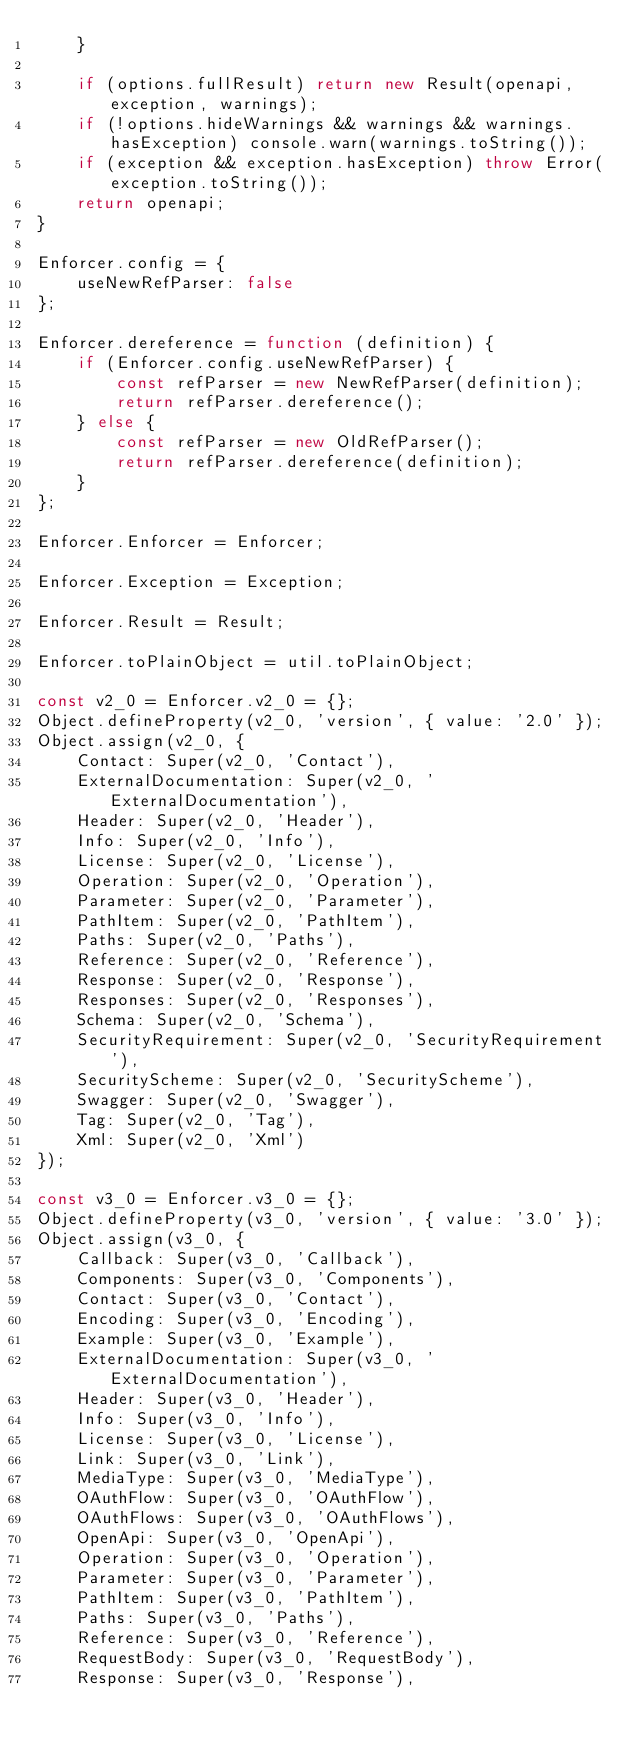<code> <loc_0><loc_0><loc_500><loc_500><_JavaScript_>    }

    if (options.fullResult) return new Result(openapi, exception, warnings);
    if (!options.hideWarnings && warnings && warnings.hasException) console.warn(warnings.toString());
    if (exception && exception.hasException) throw Error(exception.toString());
    return openapi;
}

Enforcer.config = {
    useNewRefParser: false
};

Enforcer.dereference = function (definition) {
    if (Enforcer.config.useNewRefParser) {
        const refParser = new NewRefParser(definition);
        return refParser.dereference();
    } else {
        const refParser = new OldRefParser();
        return refParser.dereference(definition);
    }
};

Enforcer.Enforcer = Enforcer;

Enforcer.Exception = Exception;

Enforcer.Result = Result;

Enforcer.toPlainObject = util.toPlainObject;

const v2_0 = Enforcer.v2_0 = {};
Object.defineProperty(v2_0, 'version', { value: '2.0' });
Object.assign(v2_0, {
    Contact: Super(v2_0, 'Contact'),
    ExternalDocumentation: Super(v2_0, 'ExternalDocumentation'),
    Header: Super(v2_0, 'Header'),
    Info: Super(v2_0, 'Info'),
    License: Super(v2_0, 'License'),
    Operation: Super(v2_0, 'Operation'),
    Parameter: Super(v2_0, 'Parameter'),
    PathItem: Super(v2_0, 'PathItem'),
    Paths: Super(v2_0, 'Paths'),
    Reference: Super(v2_0, 'Reference'),
    Response: Super(v2_0, 'Response'),
    Responses: Super(v2_0, 'Responses'),
    Schema: Super(v2_0, 'Schema'),
    SecurityRequirement: Super(v2_0, 'SecurityRequirement'),
    SecurityScheme: Super(v2_0, 'SecurityScheme'),
    Swagger: Super(v2_0, 'Swagger'),
    Tag: Super(v2_0, 'Tag'),
    Xml: Super(v2_0, 'Xml')
});

const v3_0 = Enforcer.v3_0 = {};
Object.defineProperty(v3_0, 'version', { value: '3.0' });
Object.assign(v3_0, {
    Callback: Super(v3_0, 'Callback'),
    Components: Super(v3_0, 'Components'),
    Contact: Super(v3_0, 'Contact'),
    Encoding: Super(v3_0, 'Encoding'),
    Example: Super(v3_0, 'Example'),
    ExternalDocumentation: Super(v3_0, 'ExternalDocumentation'),
    Header: Super(v3_0, 'Header'),
    Info: Super(v3_0, 'Info'),
    License: Super(v3_0, 'License'),
    Link: Super(v3_0, 'Link'),
    MediaType: Super(v3_0, 'MediaType'),
    OAuthFlow: Super(v3_0, 'OAuthFlow'),
    OAuthFlows: Super(v3_0, 'OAuthFlows'),
    OpenApi: Super(v3_0, 'OpenApi'),
    Operation: Super(v3_0, 'Operation'),
    Parameter: Super(v3_0, 'Parameter'),
    PathItem: Super(v3_0, 'PathItem'),
    Paths: Super(v3_0, 'Paths'),
    Reference: Super(v3_0, 'Reference'),
    RequestBody: Super(v3_0, 'RequestBody'),
    Response: Super(v3_0, 'Response'),</code> 